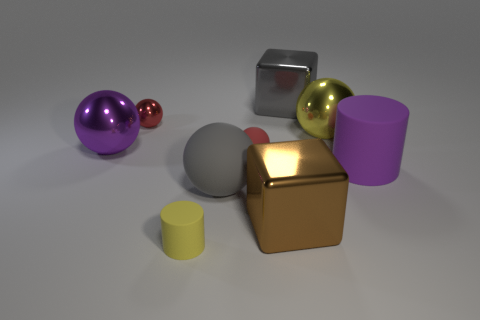What number of other things are the same shape as the tiny metal thing?
Keep it short and to the point. 4. How many objects are either gray cubes or large brown cubes?
Your response must be concise. 2. Does the small matte cylinder have the same color as the big matte ball?
Your response must be concise. No. The large purple thing that is to the right of the rubber cylinder in front of the large rubber cylinder is what shape?
Your answer should be very brief. Cylinder. Are there fewer brown things than metallic things?
Make the answer very short. Yes. There is a thing that is both to the left of the red rubber ball and right of the small yellow object; how big is it?
Provide a succinct answer. Large. Is the yellow cylinder the same size as the yellow ball?
Ensure brevity in your answer.  No. There is a tiny object behind the tiny matte ball; is it the same color as the small matte sphere?
Ensure brevity in your answer.  Yes. There is a big purple metallic object; how many red objects are behind it?
Offer a terse response. 1. Are there more big yellow metallic spheres than cubes?
Keep it short and to the point. No. 